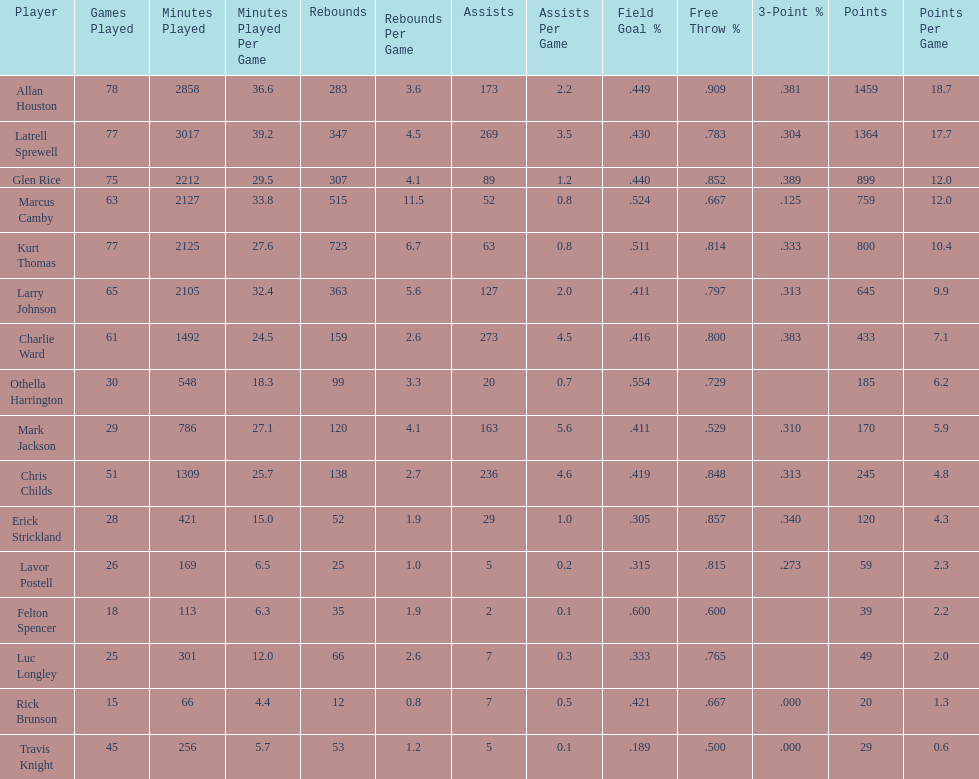What was the overall number of points scored by players with an average of more than 4 assists per game? 848. 